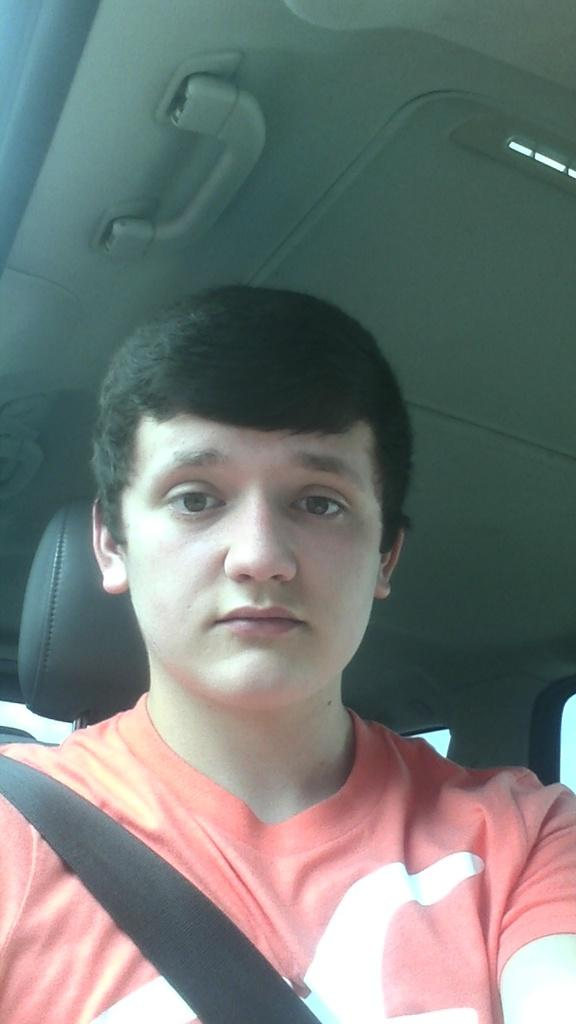What is the person in the image doing? The person is sitting in a vehicle in the image. What part of the vehicle can be seen in the image? The roof of the vehicle is visible in the image. What type of jeans is the person wearing in the image? There is no information about the person's clothing in the image, so it cannot be determined if they are wearing jeans or any other type of clothing. 